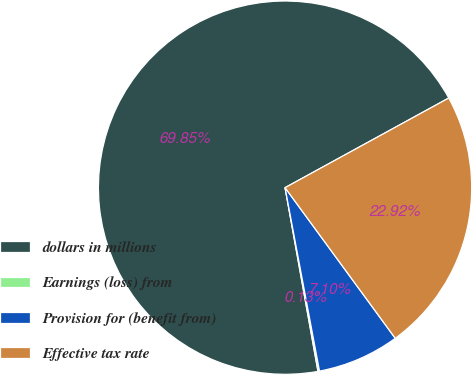<chart> <loc_0><loc_0><loc_500><loc_500><pie_chart><fcel>dollars in millions<fcel>Earnings (loss) from<fcel>Provision for (benefit from)<fcel>Effective tax rate<nl><fcel>69.85%<fcel>0.13%<fcel>7.1%<fcel>22.92%<nl></chart> 